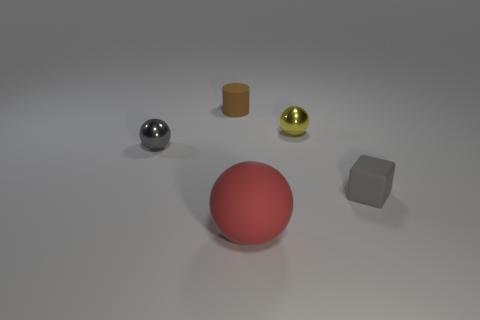Is there anything else that has the same size as the red rubber ball?
Provide a short and direct response. No. Are there any other things that have the same shape as the brown object?
Your answer should be compact. No. There is a gray object that is to the left of the large object; does it have the same shape as the object that is in front of the small matte cube?
Give a very brief answer. Yes. There is another yellow thing that is the same shape as the big matte object; what is it made of?
Make the answer very short. Metal. What number of balls are large red matte objects or small gray shiny things?
Your answer should be very brief. 2. How many small brown things are the same material as the tiny yellow thing?
Your answer should be compact. 0. Is the material of the small sphere that is to the right of the big sphere the same as the small ball that is to the left of the small rubber cylinder?
Provide a short and direct response. Yes. What number of blocks are on the right side of the tiny object behind the metallic ball right of the tiny cylinder?
Provide a succinct answer. 1. There is a ball that is to the right of the big matte sphere; is it the same color as the small metal sphere to the left of the small cylinder?
Offer a very short reply. No. Are there any other things of the same color as the small matte cylinder?
Give a very brief answer. No. 